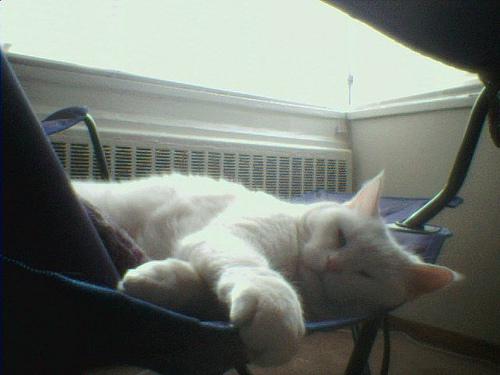Is this cat terrified?
Short answer required. No. Is there a window in the image?
Give a very brief answer. Yes. Could this chair be collapsible?
Keep it brief. Yes. What kind of chair is this?
Short answer required. Camping. 